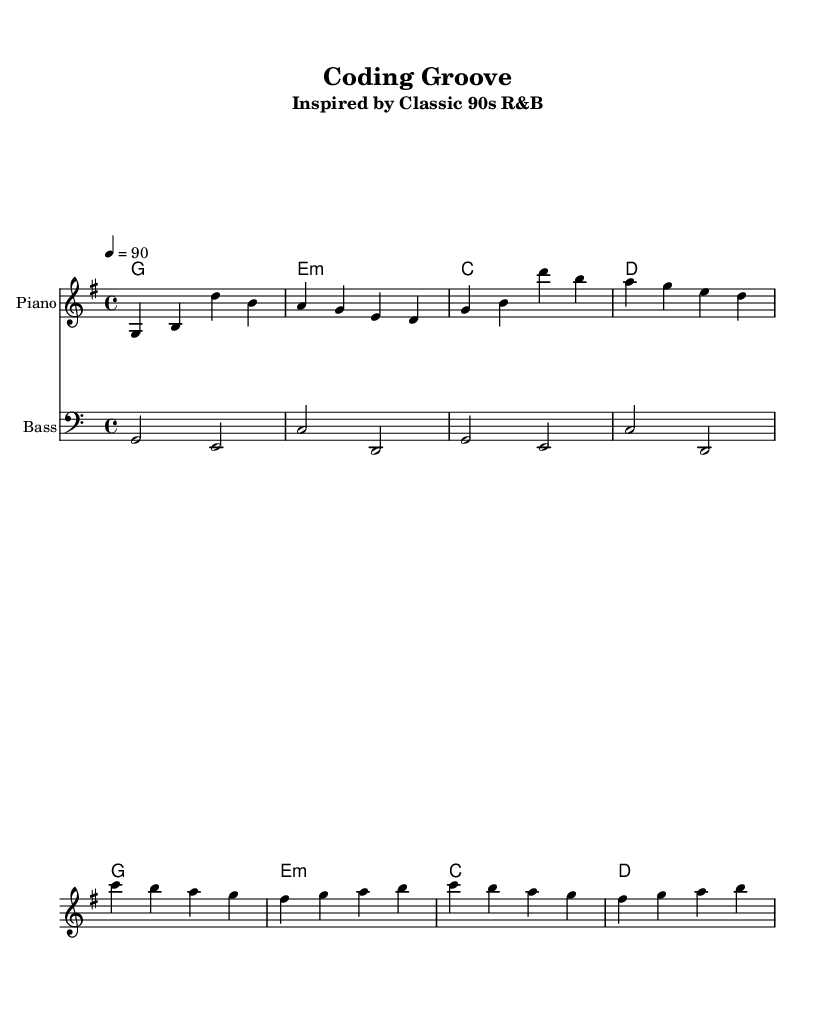What is the key signature of this music? The key signature is G major, which has one sharp (F#). You can determine the key signature by identifying the key indicated in the global settings of the sheet music.
Answer: G major What is the time signature of this music? The time signature is 4/4, indicating there are four beats in each measure and the quarter note gets one beat. This is mentioned in the global settings provided in the sheet music.
Answer: 4/4 What is the tempo of this piece? The tempo is 90 beats per minute as indicated in the global settings. This means the piece is played at a moderate pace.
Answer: 90 How many measures are in the melody section? There are eight measures in the melody section, which you can count by observing the vertical lines (bar lines) within the scales of the melody.
Answer: 8 What is the first note of the melody? The first note of the melody is G. You can identify this by looking at the first note in the relative melody section.
Answer: G What types of chords are used in the harmonies? The harmonies consist of G major, E minor, C major, and D major chords. You can identify them by looking at the chord symbols above the staff.
Answer: G major, E minor, C major, D major Why is the bass clef used in the bass section? The bass clef is used because it indicates the lower range of pitches. The bass notes are generally lower than the melody, and using the bass clef helps to read the notes more easily in that range.
Answer: Lower range 